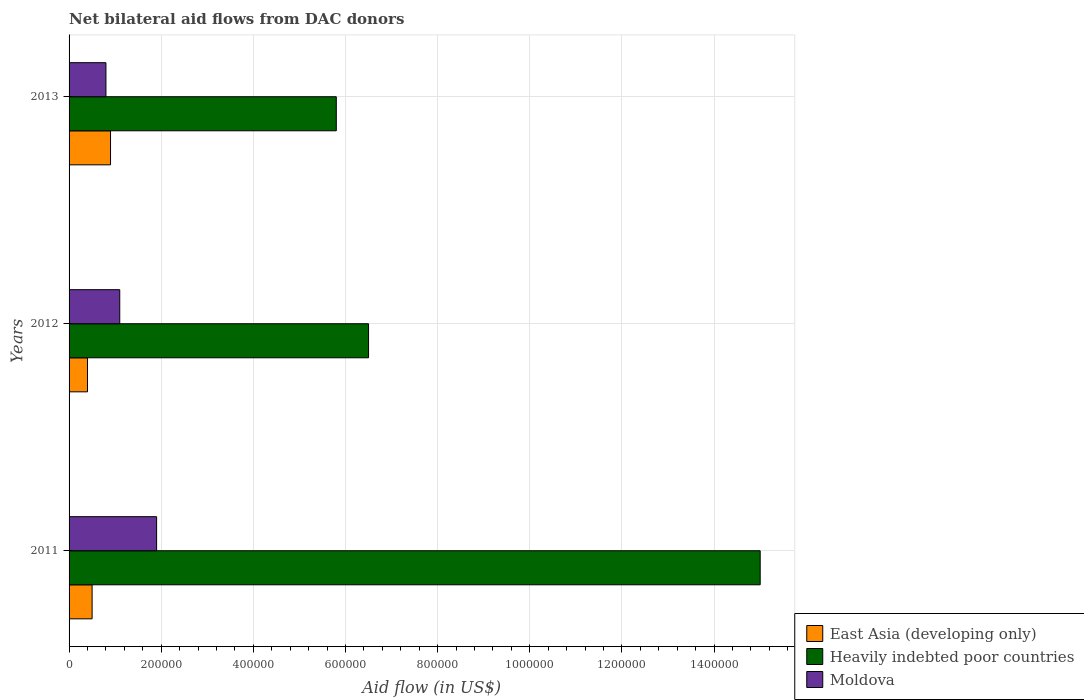How many different coloured bars are there?
Offer a very short reply. 3. How many groups of bars are there?
Offer a terse response. 3. Are the number of bars per tick equal to the number of legend labels?
Ensure brevity in your answer.  Yes. Are the number of bars on each tick of the Y-axis equal?
Provide a succinct answer. Yes. How many bars are there on the 3rd tick from the top?
Offer a terse response. 3. How many bars are there on the 1st tick from the bottom?
Provide a short and direct response. 3. In how many cases, is the number of bars for a given year not equal to the number of legend labels?
Your response must be concise. 0. What is the net bilateral aid flow in Moldova in 2013?
Make the answer very short. 8.00e+04. Across all years, what is the maximum net bilateral aid flow in East Asia (developing only)?
Your answer should be compact. 9.00e+04. Across all years, what is the minimum net bilateral aid flow in Moldova?
Your response must be concise. 8.00e+04. In which year was the net bilateral aid flow in East Asia (developing only) maximum?
Ensure brevity in your answer.  2013. In which year was the net bilateral aid flow in Heavily indebted poor countries minimum?
Offer a terse response. 2013. What is the difference between the net bilateral aid flow in Heavily indebted poor countries in 2011 and that in 2013?
Give a very brief answer. 9.20e+05. What is the difference between the net bilateral aid flow in East Asia (developing only) in 2013 and the net bilateral aid flow in Heavily indebted poor countries in 2012?
Provide a succinct answer. -5.60e+05. What is the average net bilateral aid flow in Heavily indebted poor countries per year?
Your answer should be compact. 9.10e+05. In the year 2011, what is the difference between the net bilateral aid flow in Heavily indebted poor countries and net bilateral aid flow in Moldova?
Your response must be concise. 1.31e+06. In how many years, is the net bilateral aid flow in East Asia (developing only) greater than 80000 US$?
Make the answer very short. 1. What is the ratio of the net bilateral aid flow in East Asia (developing only) in 2011 to that in 2013?
Ensure brevity in your answer.  0.56. Is the net bilateral aid flow in Heavily indebted poor countries in 2012 less than that in 2013?
Your answer should be very brief. No. What is the difference between the highest and the lowest net bilateral aid flow in East Asia (developing only)?
Your response must be concise. 5.00e+04. What does the 1st bar from the top in 2013 represents?
Provide a short and direct response. Moldova. What does the 2nd bar from the bottom in 2013 represents?
Provide a short and direct response. Heavily indebted poor countries. Are all the bars in the graph horizontal?
Your response must be concise. Yes. How many years are there in the graph?
Your response must be concise. 3. Are the values on the major ticks of X-axis written in scientific E-notation?
Ensure brevity in your answer.  No. Does the graph contain grids?
Offer a very short reply. Yes. How many legend labels are there?
Provide a short and direct response. 3. How are the legend labels stacked?
Your answer should be very brief. Vertical. What is the title of the graph?
Provide a short and direct response. Net bilateral aid flows from DAC donors. What is the label or title of the X-axis?
Ensure brevity in your answer.  Aid flow (in US$). What is the Aid flow (in US$) of Heavily indebted poor countries in 2011?
Offer a terse response. 1.50e+06. What is the Aid flow (in US$) of East Asia (developing only) in 2012?
Provide a short and direct response. 4.00e+04. What is the Aid flow (in US$) of Heavily indebted poor countries in 2012?
Your response must be concise. 6.50e+05. What is the Aid flow (in US$) of Moldova in 2012?
Your response must be concise. 1.10e+05. What is the Aid flow (in US$) in Heavily indebted poor countries in 2013?
Ensure brevity in your answer.  5.80e+05. What is the Aid flow (in US$) of Moldova in 2013?
Make the answer very short. 8.00e+04. Across all years, what is the maximum Aid flow (in US$) of East Asia (developing only)?
Your response must be concise. 9.00e+04. Across all years, what is the maximum Aid flow (in US$) of Heavily indebted poor countries?
Ensure brevity in your answer.  1.50e+06. Across all years, what is the minimum Aid flow (in US$) in East Asia (developing only)?
Offer a very short reply. 4.00e+04. Across all years, what is the minimum Aid flow (in US$) in Heavily indebted poor countries?
Your answer should be compact. 5.80e+05. What is the total Aid flow (in US$) of East Asia (developing only) in the graph?
Offer a terse response. 1.80e+05. What is the total Aid flow (in US$) in Heavily indebted poor countries in the graph?
Offer a very short reply. 2.73e+06. What is the difference between the Aid flow (in US$) in East Asia (developing only) in 2011 and that in 2012?
Your answer should be very brief. 10000. What is the difference between the Aid flow (in US$) in Heavily indebted poor countries in 2011 and that in 2012?
Provide a short and direct response. 8.50e+05. What is the difference between the Aid flow (in US$) of Moldova in 2011 and that in 2012?
Provide a short and direct response. 8.00e+04. What is the difference between the Aid flow (in US$) of East Asia (developing only) in 2011 and that in 2013?
Offer a terse response. -4.00e+04. What is the difference between the Aid flow (in US$) in Heavily indebted poor countries in 2011 and that in 2013?
Provide a short and direct response. 9.20e+05. What is the difference between the Aid flow (in US$) in Moldova in 2012 and that in 2013?
Keep it short and to the point. 3.00e+04. What is the difference between the Aid flow (in US$) of East Asia (developing only) in 2011 and the Aid flow (in US$) of Heavily indebted poor countries in 2012?
Your answer should be very brief. -6.00e+05. What is the difference between the Aid flow (in US$) in East Asia (developing only) in 2011 and the Aid flow (in US$) in Moldova in 2012?
Give a very brief answer. -6.00e+04. What is the difference between the Aid flow (in US$) in Heavily indebted poor countries in 2011 and the Aid flow (in US$) in Moldova in 2012?
Your answer should be compact. 1.39e+06. What is the difference between the Aid flow (in US$) in East Asia (developing only) in 2011 and the Aid flow (in US$) in Heavily indebted poor countries in 2013?
Ensure brevity in your answer.  -5.30e+05. What is the difference between the Aid flow (in US$) in East Asia (developing only) in 2011 and the Aid flow (in US$) in Moldova in 2013?
Your answer should be compact. -3.00e+04. What is the difference between the Aid flow (in US$) of Heavily indebted poor countries in 2011 and the Aid flow (in US$) of Moldova in 2013?
Give a very brief answer. 1.42e+06. What is the difference between the Aid flow (in US$) of East Asia (developing only) in 2012 and the Aid flow (in US$) of Heavily indebted poor countries in 2013?
Make the answer very short. -5.40e+05. What is the difference between the Aid flow (in US$) of Heavily indebted poor countries in 2012 and the Aid flow (in US$) of Moldova in 2013?
Offer a terse response. 5.70e+05. What is the average Aid flow (in US$) in East Asia (developing only) per year?
Your answer should be compact. 6.00e+04. What is the average Aid flow (in US$) in Heavily indebted poor countries per year?
Your answer should be very brief. 9.10e+05. What is the average Aid flow (in US$) of Moldova per year?
Provide a short and direct response. 1.27e+05. In the year 2011, what is the difference between the Aid flow (in US$) of East Asia (developing only) and Aid flow (in US$) of Heavily indebted poor countries?
Keep it short and to the point. -1.45e+06. In the year 2011, what is the difference between the Aid flow (in US$) of East Asia (developing only) and Aid flow (in US$) of Moldova?
Keep it short and to the point. -1.40e+05. In the year 2011, what is the difference between the Aid flow (in US$) in Heavily indebted poor countries and Aid flow (in US$) in Moldova?
Your response must be concise. 1.31e+06. In the year 2012, what is the difference between the Aid flow (in US$) in East Asia (developing only) and Aid flow (in US$) in Heavily indebted poor countries?
Your response must be concise. -6.10e+05. In the year 2012, what is the difference between the Aid flow (in US$) in East Asia (developing only) and Aid flow (in US$) in Moldova?
Give a very brief answer. -7.00e+04. In the year 2012, what is the difference between the Aid flow (in US$) of Heavily indebted poor countries and Aid flow (in US$) of Moldova?
Keep it short and to the point. 5.40e+05. In the year 2013, what is the difference between the Aid flow (in US$) in East Asia (developing only) and Aid flow (in US$) in Heavily indebted poor countries?
Your answer should be compact. -4.90e+05. In the year 2013, what is the difference between the Aid flow (in US$) in Heavily indebted poor countries and Aid flow (in US$) in Moldova?
Keep it short and to the point. 5.00e+05. What is the ratio of the Aid flow (in US$) in Heavily indebted poor countries in 2011 to that in 2012?
Your response must be concise. 2.31. What is the ratio of the Aid flow (in US$) in Moldova in 2011 to that in 2012?
Offer a very short reply. 1.73. What is the ratio of the Aid flow (in US$) of East Asia (developing only) in 2011 to that in 2013?
Offer a terse response. 0.56. What is the ratio of the Aid flow (in US$) of Heavily indebted poor countries in 2011 to that in 2013?
Keep it short and to the point. 2.59. What is the ratio of the Aid flow (in US$) of Moldova in 2011 to that in 2013?
Ensure brevity in your answer.  2.38. What is the ratio of the Aid flow (in US$) in East Asia (developing only) in 2012 to that in 2013?
Your answer should be very brief. 0.44. What is the ratio of the Aid flow (in US$) of Heavily indebted poor countries in 2012 to that in 2013?
Give a very brief answer. 1.12. What is the ratio of the Aid flow (in US$) in Moldova in 2012 to that in 2013?
Provide a short and direct response. 1.38. What is the difference between the highest and the second highest Aid flow (in US$) in Heavily indebted poor countries?
Offer a very short reply. 8.50e+05. What is the difference between the highest and the lowest Aid flow (in US$) in Heavily indebted poor countries?
Keep it short and to the point. 9.20e+05. What is the difference between the highest and the lowest Aid flow (in US$) in Moldova?
Offer a very short reply. 1.10e+05. 